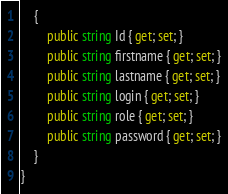<code> <loc_0><loc_0><loc_500><loc_500><_C#_>    {
        public string Id { get; set; }
        public string firstname { get; set; }
        public string lastname { get; set; }
        public string login { get; set; }
        public string role { get; set; }
        public string password { get; set; }
    }
}
</code> 